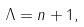<formula> <loc_0><loc_0><loc_500><loc_500>\Lambda = n + 1 ,</formula> 